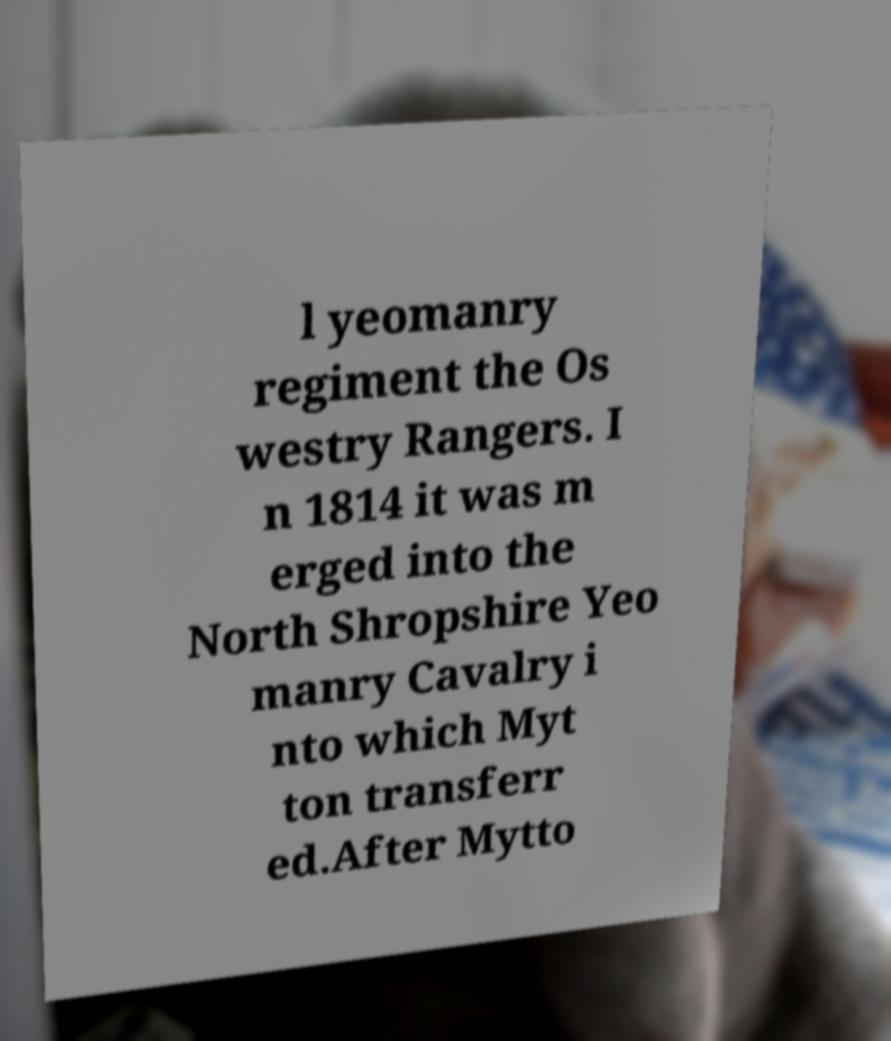What messages or text are displayed in this image? I need them in a readable, typed format. l yeomanry regiment the Os westry Rangers. I n 1814 it was m erged into the North Shropshire Yeo manry Cavalry i nto which Myt ton transferr ed.After Mytto 